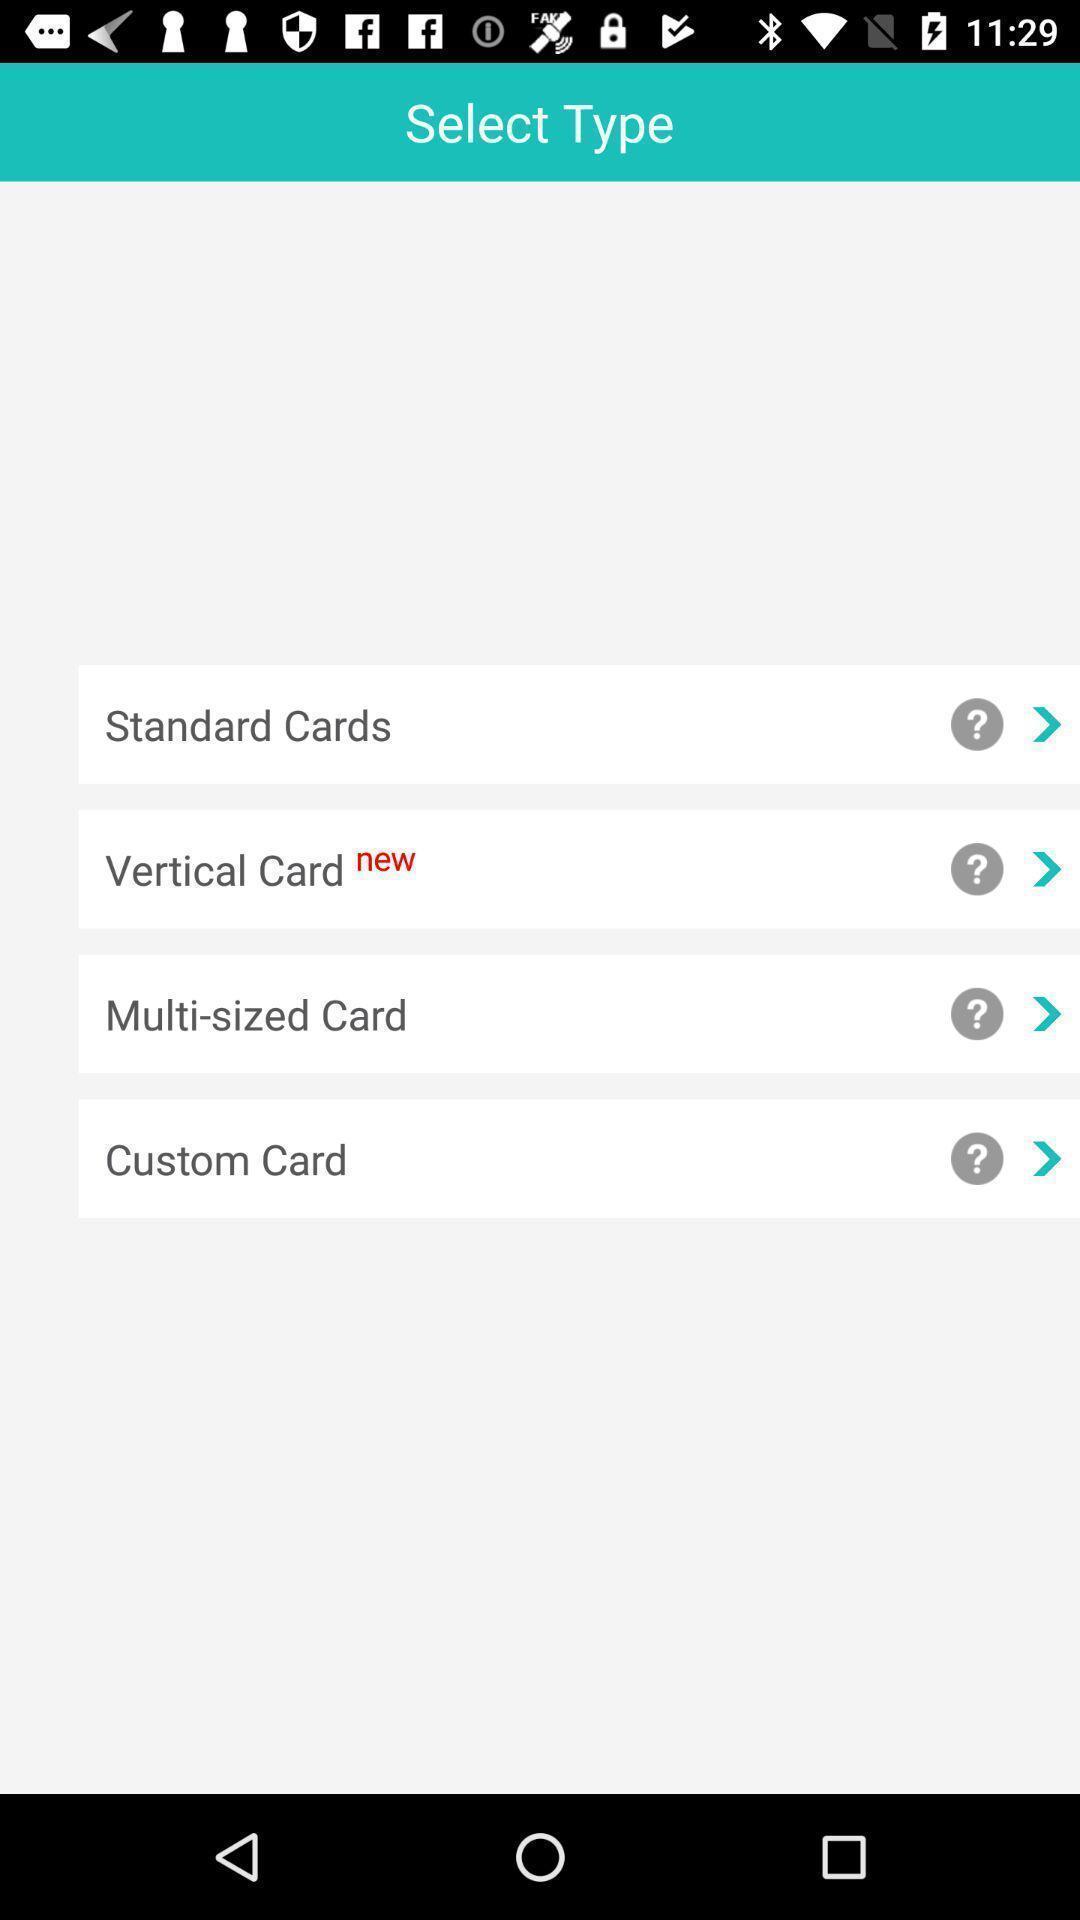Provide a textual representation of this image. Screen shows list type of cards. 